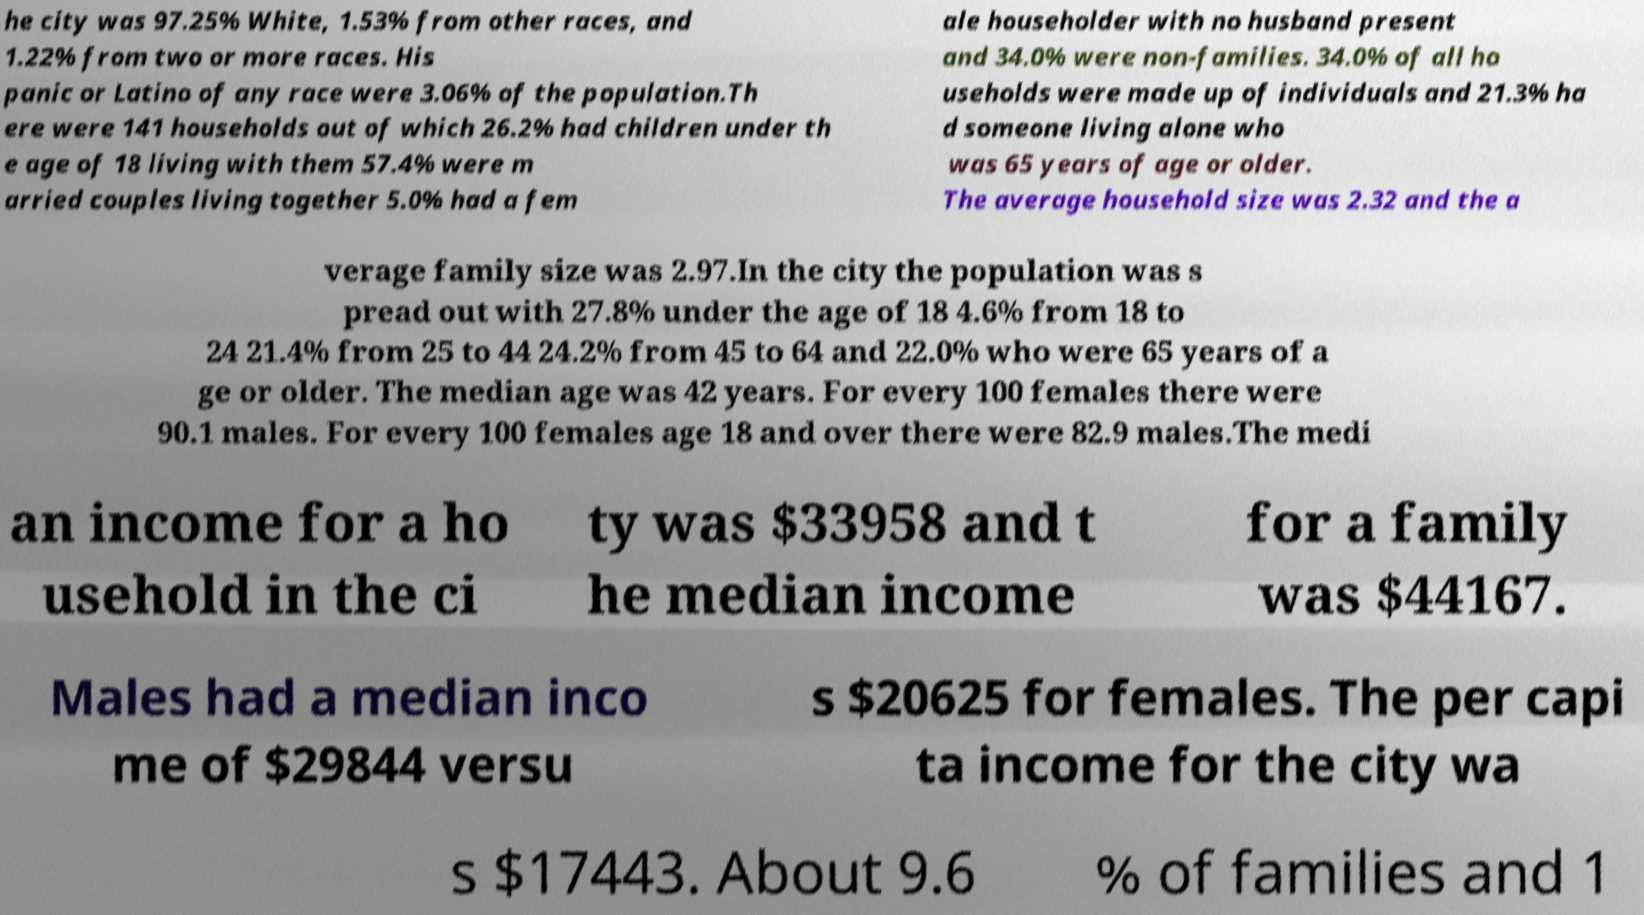Can you accurately transcribe the text from the provided image for me? he city was 97.25% White, 1.53% from other races, and 1.22% from two or more races. His panic or Latino of any race were 3.06% of the population.Th ere were 141 households out of which 26.2% had children under th e age of 18 living with them 57.4% were m arried couples living together 5.0% had a fem ale householder with no husband present and 34.0% were non-families. 34.0% of all ho useholds were made up of individuals and 21.3% ha d someone living alone who was 65 years of age or older. The average household size was 2.32 and the a verage family size was 2.97.In the city the population was s pread out with 27.8% under the age of 18 4.6% from 18 to 24 21.4% from 25 to 44 24.2% from 45 to 64 and 22.0% who were 65 years of a ge or older. The median age was 42 years. For every 100 females there were 90.1 males. For every 100 females age 18 and over there were 82.9 males.The medi an income for a ho usehold in the ci ty was $33958 and t he median income for a family was $44167. Males had a median inco me of $29844 versu s $20625 for females. The per capi ta income for the city wa s $17443. About 9.6 % of families and 1 